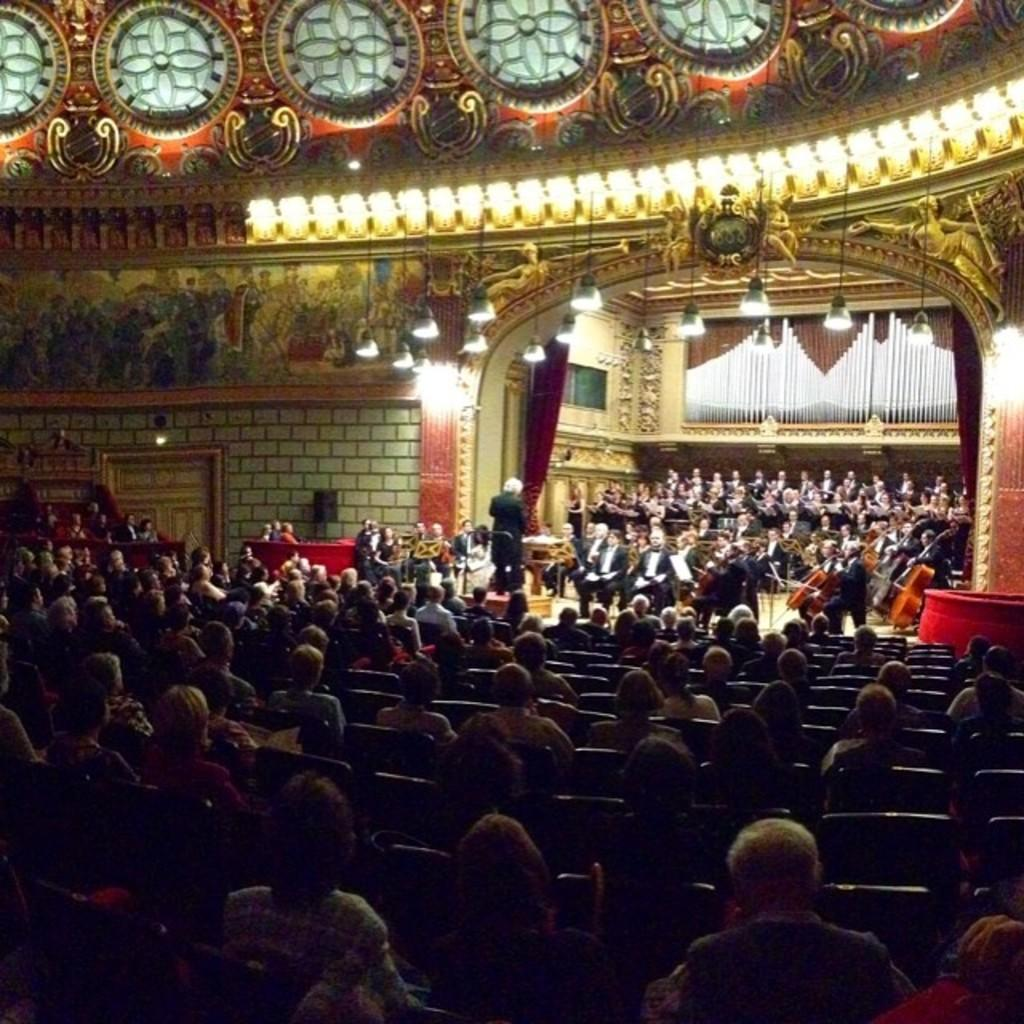What are the people in the image doing? Some of the people are playing musical instruments. How many people are in the room? The number of people in the room is not specified, but there are at least a few people present. What can be seen on the roof in the image? There are lights attached to the roof. Can you tell me how many donkeys are in the room with the people? There is no mention of donkeys in the image; the people are playing musical instruments in a room with lights attached to the roof. 